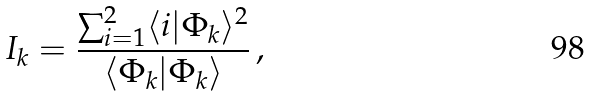Convert formula to latex. <formula><loc_0><loc_0><loc_500><loc_500>I _ { k } = \frac { \sum _ { i = 1 } ^ { 2 } \langle i | \Phi _ { k } \rangle ^ { 2 } } { \langle \Phi _ { k } | \Phi _ { k } \rangle } \, ,</formula> 